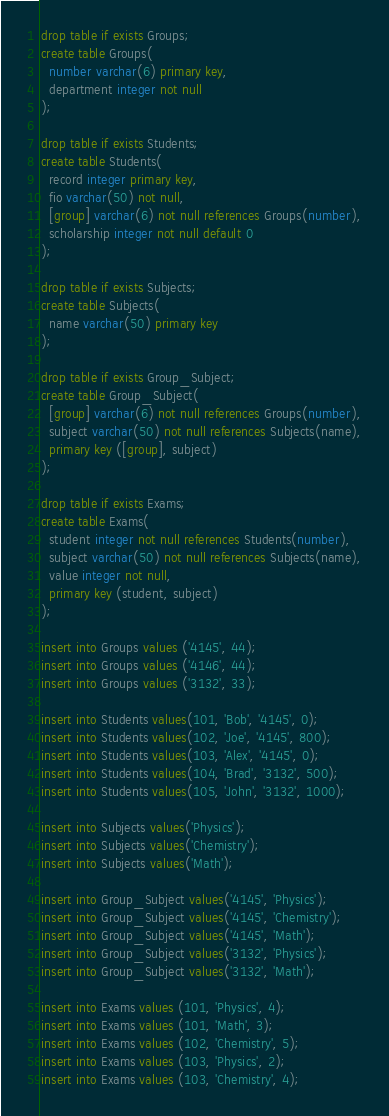<code> <loc_0><loc_0><loc_500><loc_500><_SQL_>drop table if exists Groups;
create table Groups(
  number varchar(6) primary key,
  department integer not null
);

drop table if exists Students;
create table Students(
  record integer primary key,
  fio varchar(50) not null,
  [group] varchar(6) not null references Groups(number),
  scholarship integer not null default 0
);

drop table if exists Subjects;
create table Subjects(
  name varchar(50) primary key
);

drop table if exists Group_Subject;
create table Group_Subject(
  [group] varchar(6) not null references Groups(number),
  subject varchar(50) not null references Subjects(name),
  primary key ([group], subject)
);

drop table if exists Exams;
create table Exams(
  student integer not null references Students(number),
  subject varchar(50) not null references Subjects(name),
  value integer not null,
  primary key (student, subject)
);

insert into Groups values ('4145', 44);
insert into Groups values ('4146', 44);
insert into Groups values ('3132', 33);

insert into Students values(101, 'Bob', '4145', 0);
insert into Students values(102, 'Joe', '4145', 800);
insert into Students values(103, 'Alex', '4145', 0);
insert into Students values(104, 'Brad', '3132', 500);
insert into Students values(105, 'John', '3132', 1000);

insert into Subjects values('Physics');
insert into Subjects values('Chemistry');
insert into Subjects values('Math');

insert into Group_Subject values('4145', 'Physics');
insert into Group_Subject values('4145', 'Chemistry');
insert into Group_Subject values('4145', 'Math');
insert into Group_Subject values('3132', 'Physics');
insert into Group_Subject values('3132', 'Math');

insert into Exams values (101, 'Physics', 4);
insert into Exams values (101, 'Math', 3);
insert into Exams values (102, 'Chemistry', 5);
insert into Exams values (103, 'Physics', 2);
insert into Exams values (103, 'Chemistry', 4);
</code> 